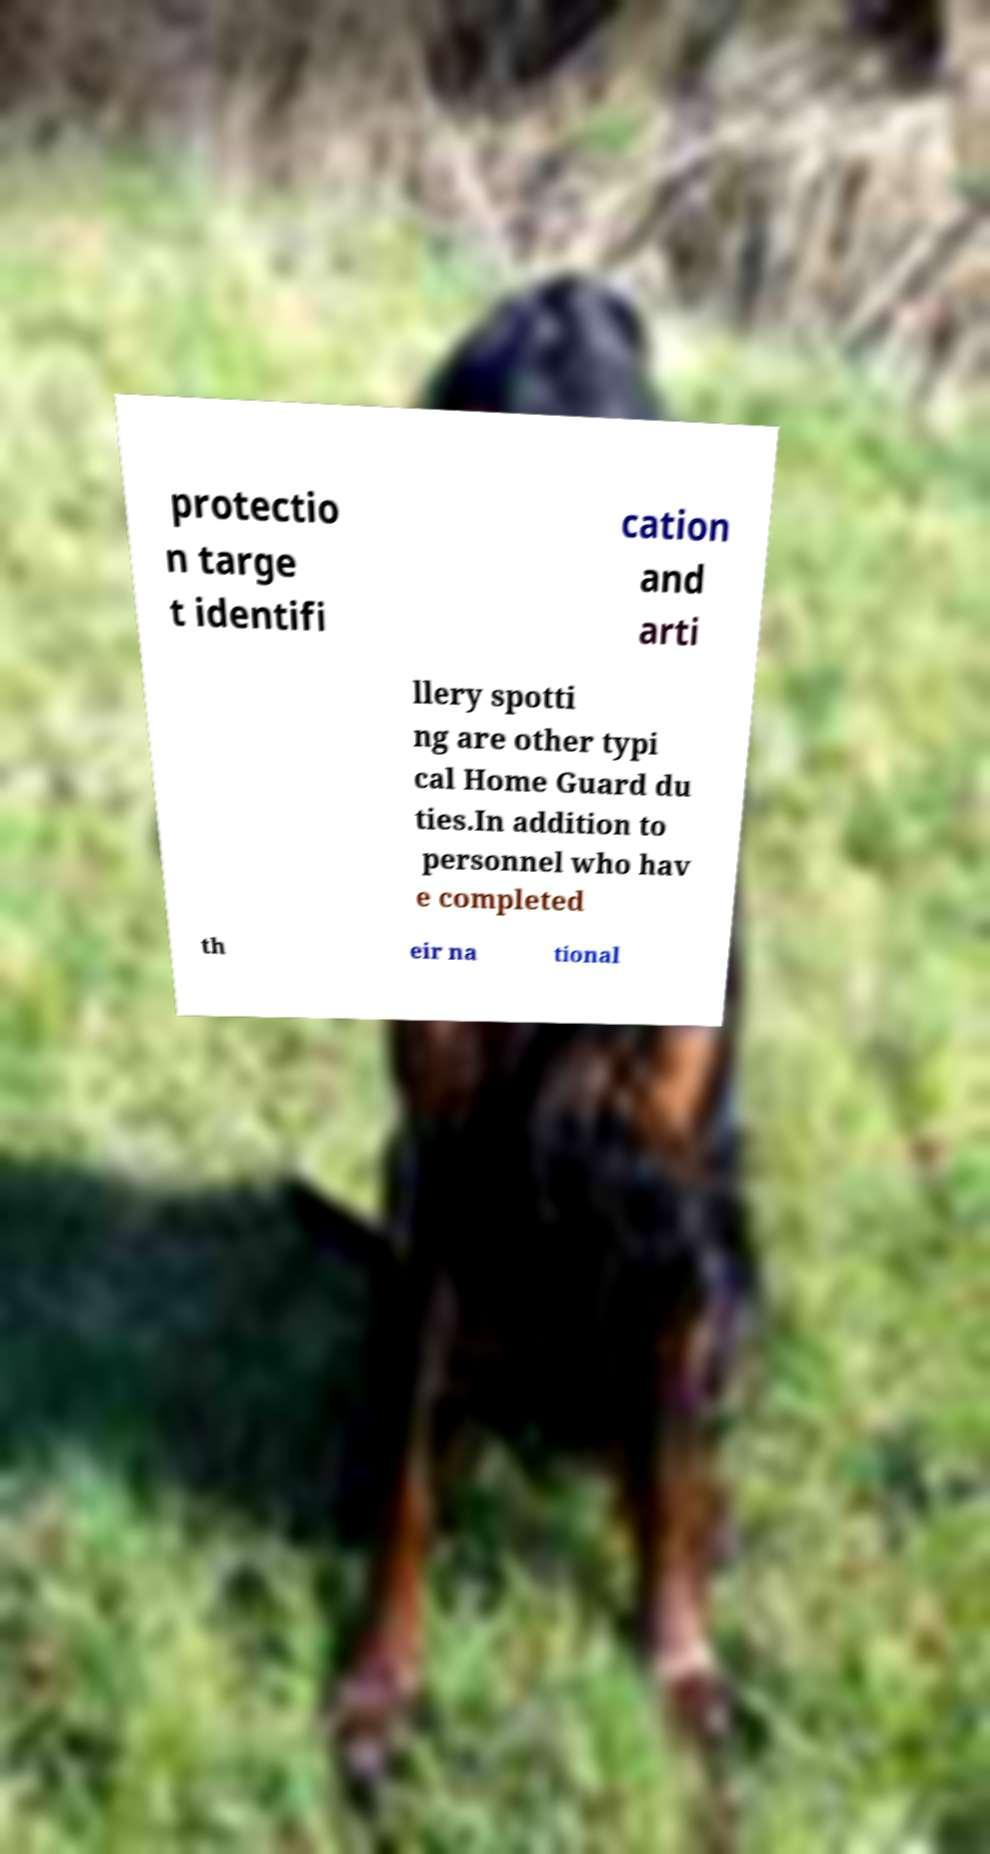Could you extract and type out the text from this image? protectio n targe t identifi cation and arti llery spotti ng are other typi cal Home Guard du ties.In addition to personnel who hav e completed th eir na tional 